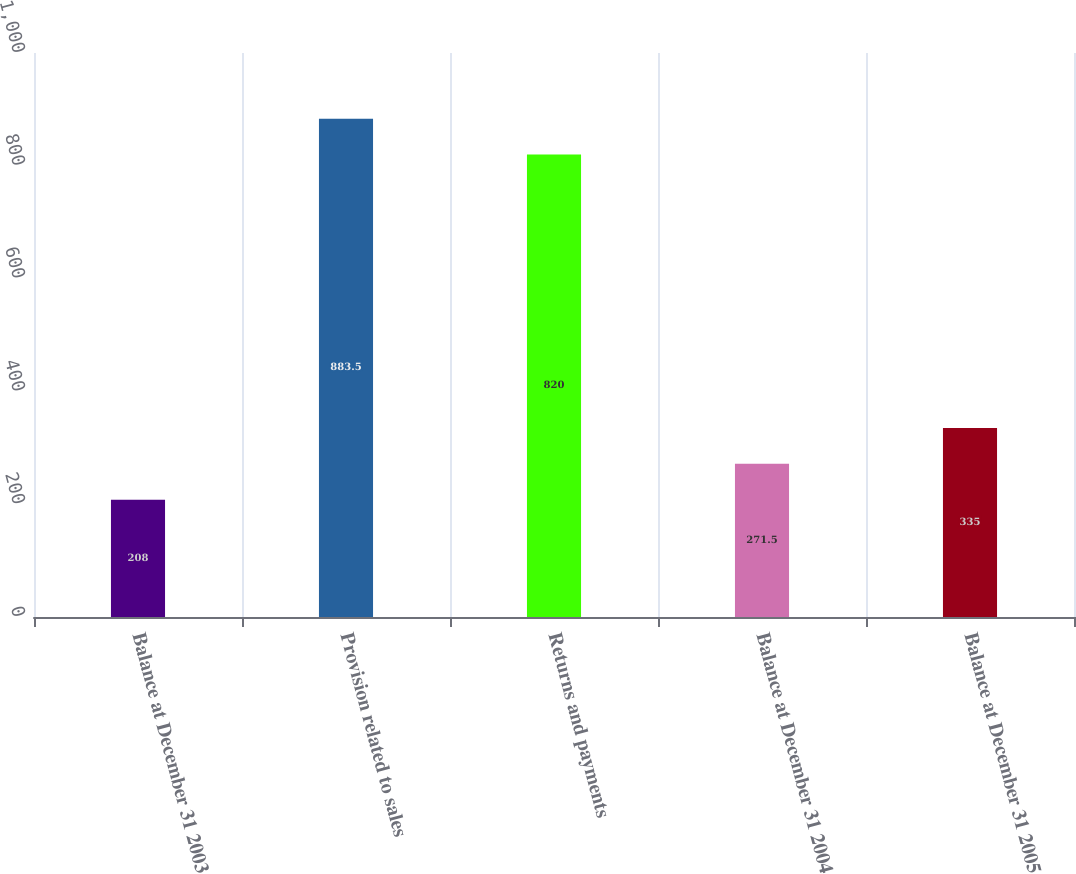<chart> <loc_0><loc_0><loc_500><loc_500><bar_chart><fcel>Balance at December 31 2003<fcel>Provision related to sales<fcel>Returns and payments<fcel>Balance at December 31 2004<fcel>Balance at December 31 2005<nl><fcel>208<fcel>883.5<fcel>820<fcel>271.5<fcel>335<nl></chart> 